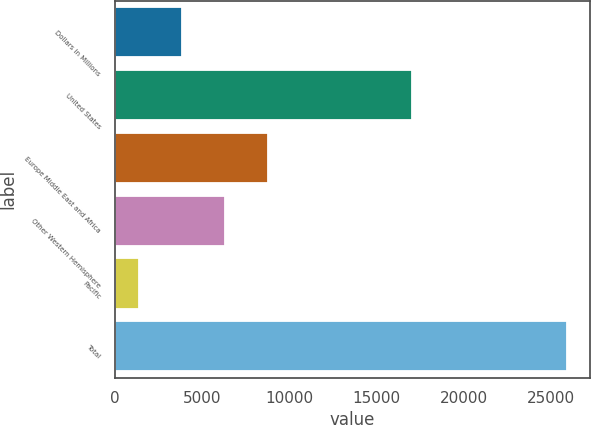Convert chart. <chart><loc_0><loc_0><loc_500><loc_500><bar_chart><fcel>Dollars in Millions<fcel>United States<fcel>Europe Middle East and Africa<fcel>Other Western Hemisphere<fcel>Pacific<fcel>Total<nl><fcel>3870.6<fcel>17008<fcel>8771.8<fcel>6321.2<fcel>1420<fcel>25926<nl></chart> 